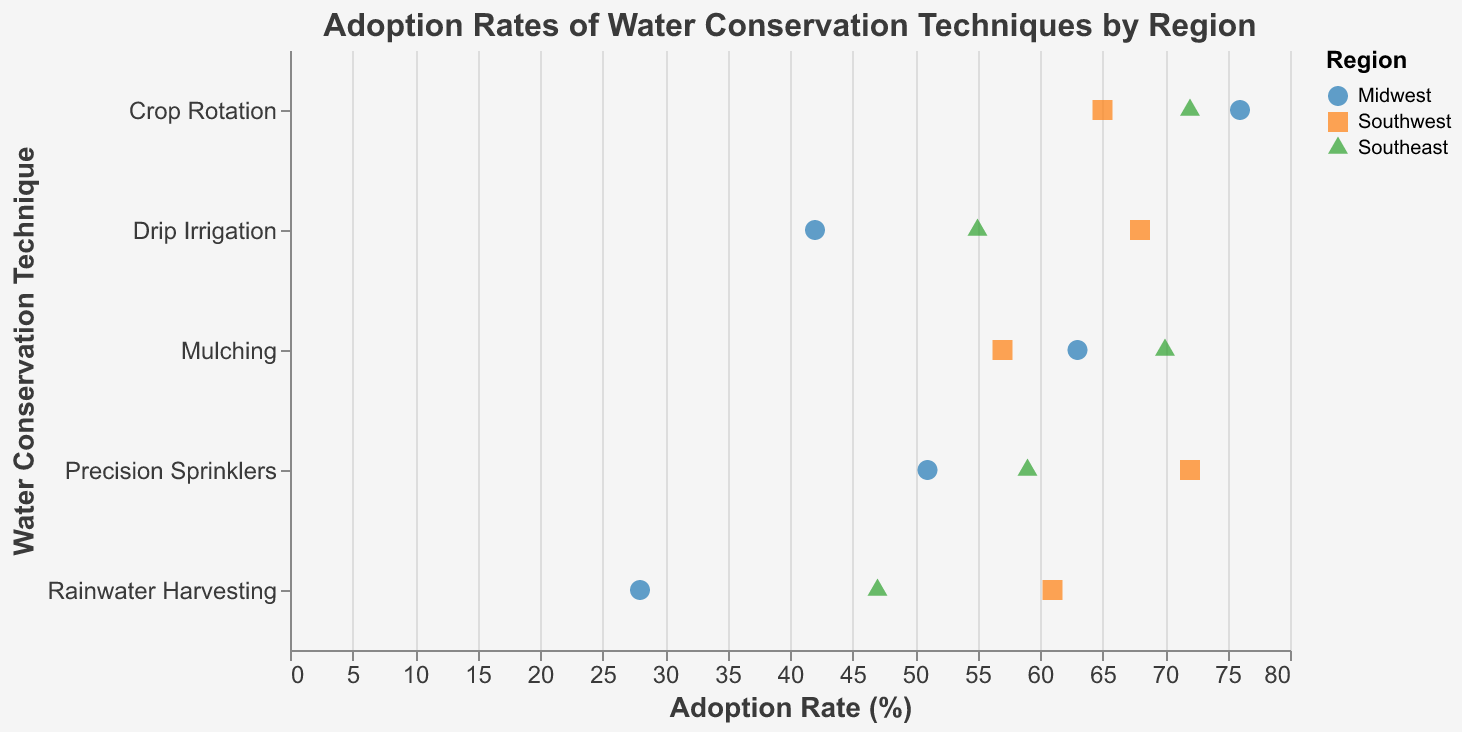What is the title of the plot? The title is usually located at the top of the plot, indicating what the plot is about. For this plot, the title is clearly shown at the top.
Answer: Adoption Rates of Water Conservation Techniques by Region What is the adoption rate of Drip Irrigation in the Southeast region? To find this, look for the data point related to Drip Irrigation and identify the symbol corresponding to the Southeast region. The adoption rate is shown next to the icon.
Answer: 55 Which region has the highest adoption rate for Rainwater Harvesting? Compare the adoption rates for Rainwater Harvesting across the Midwest, Southwest, and Southeast regions. Identify the region with the highest value.
Answer: Southwest What is the average adoption rate of Precision Sprinklers across all regions? Add the adoption rates for Precision Sprinklers in Midwest (51), Southwest (72), and Southeast (59), then divide by the number of regions (3). (51+72+59)/3 = 182/3 = 60.67
Answer: 60.67 How does Mulching adoption rate in the Midwest compare to the Southwest? Look for adoption rates for Mulching in both Midwest and Southwest, then compare them directly.
Answer: Higher in Midwest (63 vs. 57) Which water conservation technique has the most uniform adoption rate across all regions? Check the spread of adoption rates for each technique across all regions, and identify which technique has the closest values across the board.
Answer: Crop Rotation What is the range of adoption rates for Crop Rotation? Identify the highest and lowest adoption rates for Crop Rotation across all regions, then subtract the lowest from the highest. Highest: Southeast (72), Lowest: Southwest (65), Range: 72 - 65 = 7
Answer: 7 Between Drip Irrigation and Mulching, which technique has a higher average adoption rate? Calculate the average adoption rate for Drip Irrigation (42+68+55)/3 = 55 and for Mulching (63+57+70)/3 = 63.33, then compare the two averages.
Answer: Mulching Which region has the highest overall adoption rate across all techniques? Sum the adoption rates for all techniques within each region and find the region with the highest total. Midwest: 42+28+51+63+76=260 Southwest: 68+61+72+57+65=323 Southeast: 55+47+59+70+72=303 Highest: Southwest
Answer: Southwest 